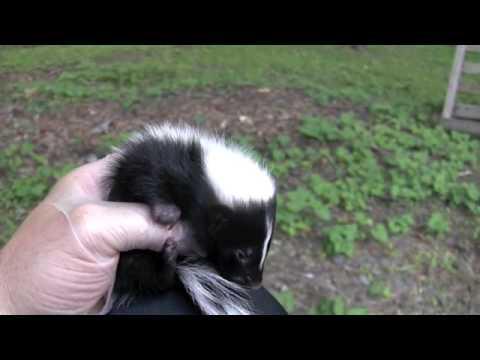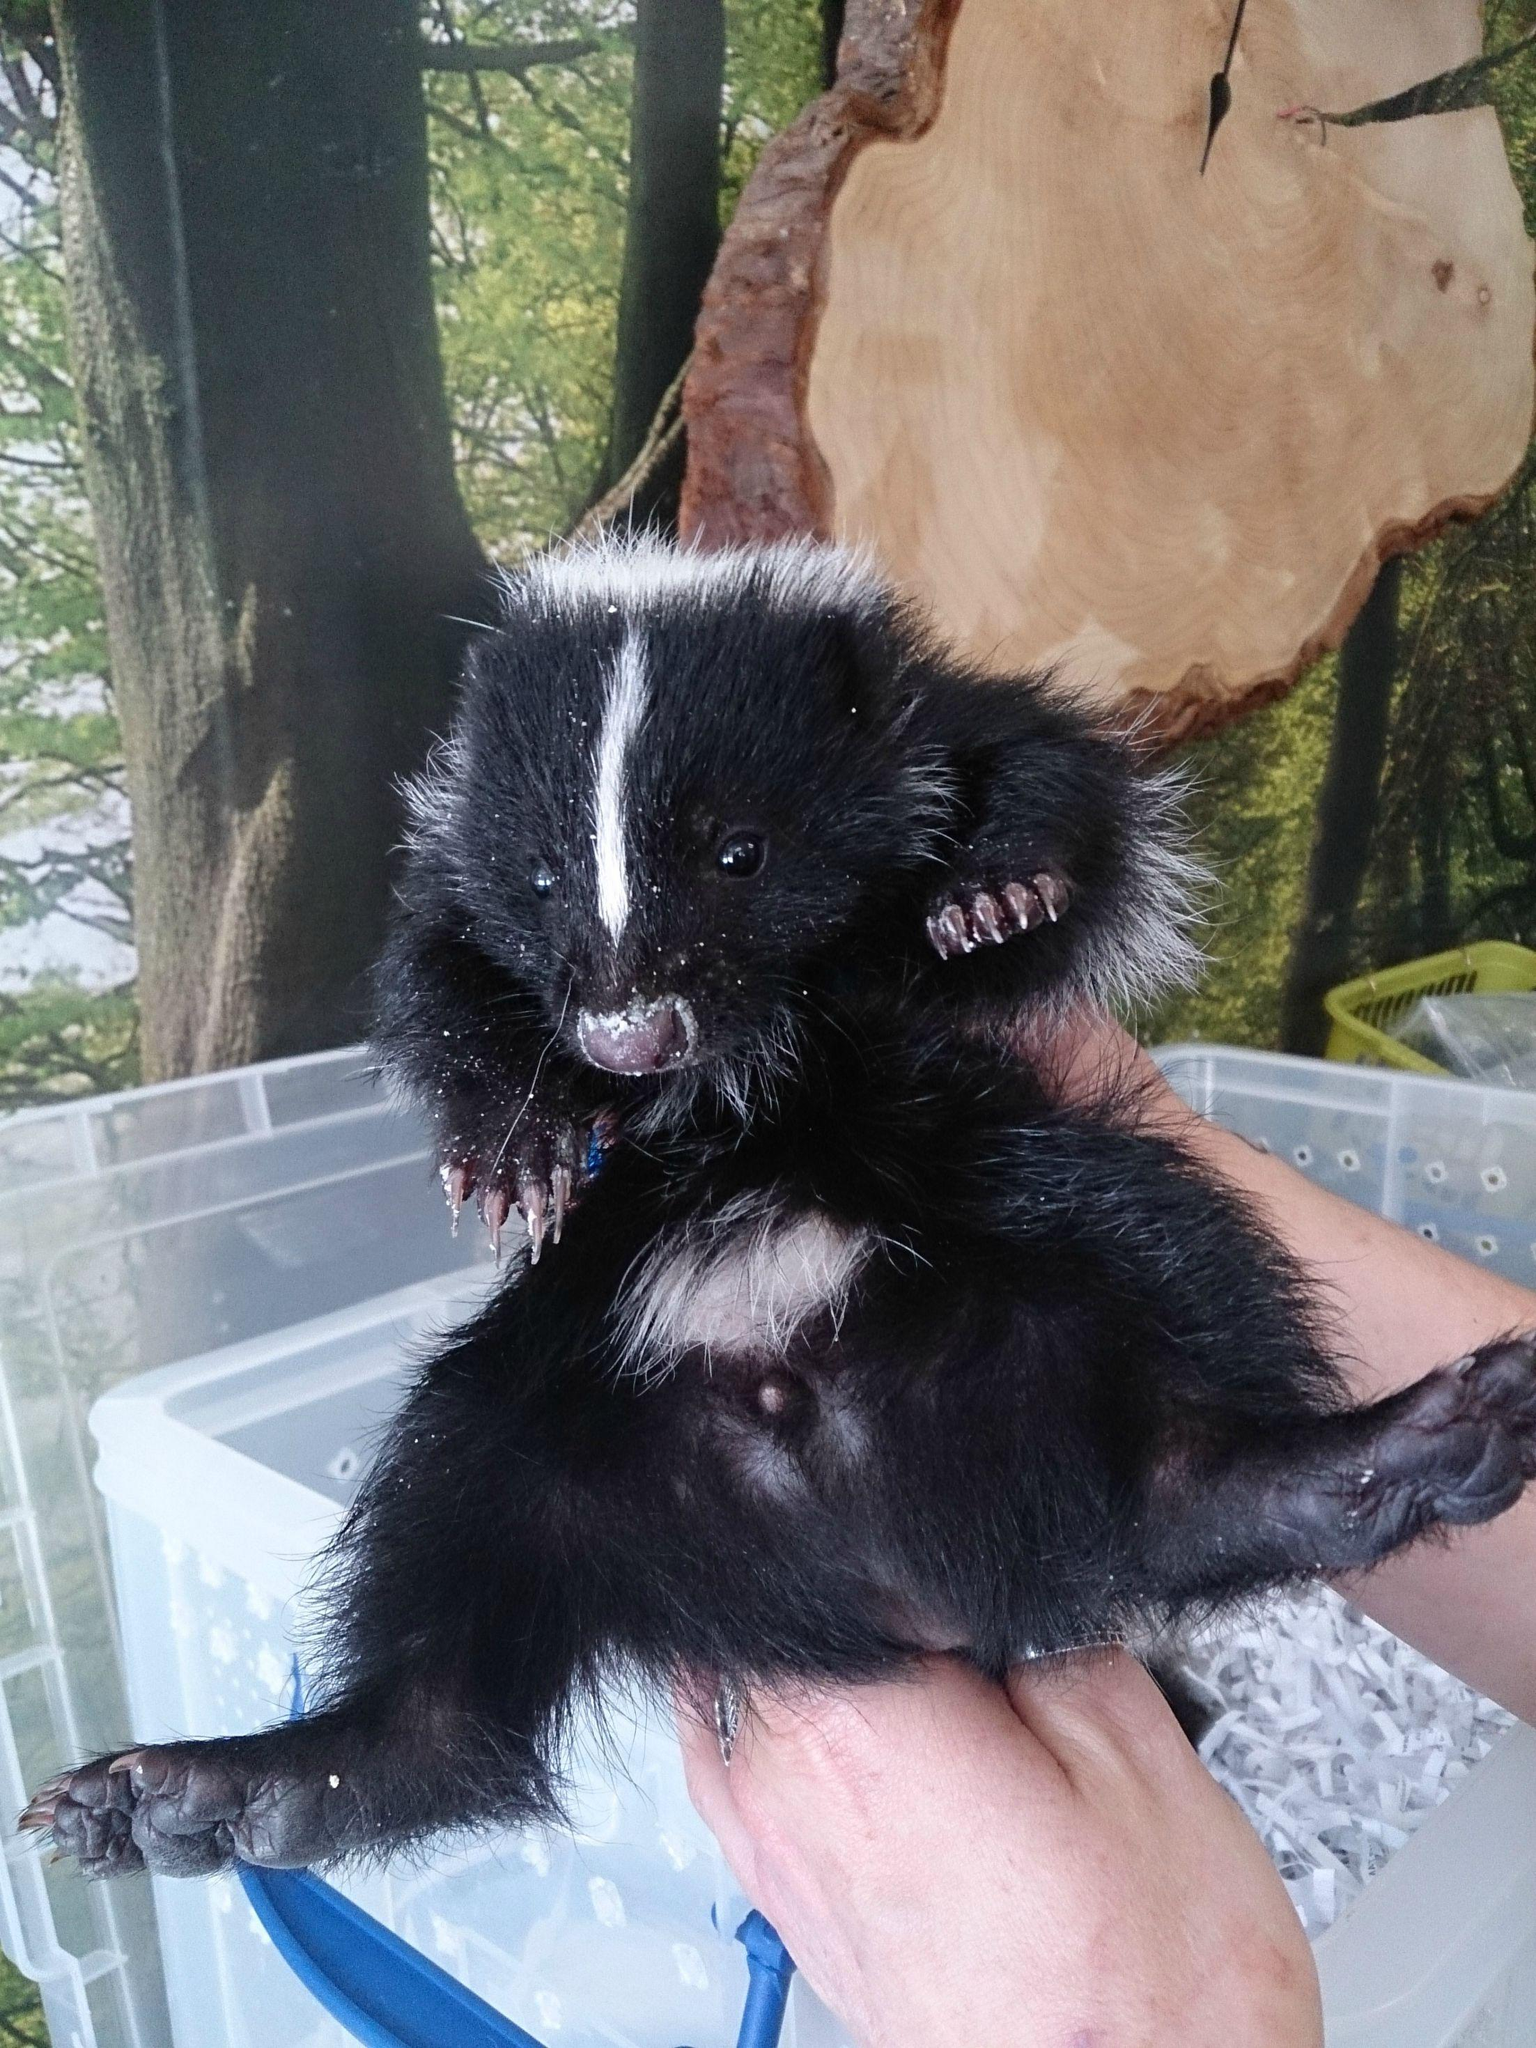The first image is the image on the left, the second image is the image on the right. Given the left and right images, does the statement "One image shows a reclining mother cat with a kitten and a skunk in front of it." hold true? Answer yes or no. No. The first image is the image on the left, the second image is the image on the right. Examine the images to the left and right. Is the description "There is more than one species of animal." accurate? Answer yes or no. No. 